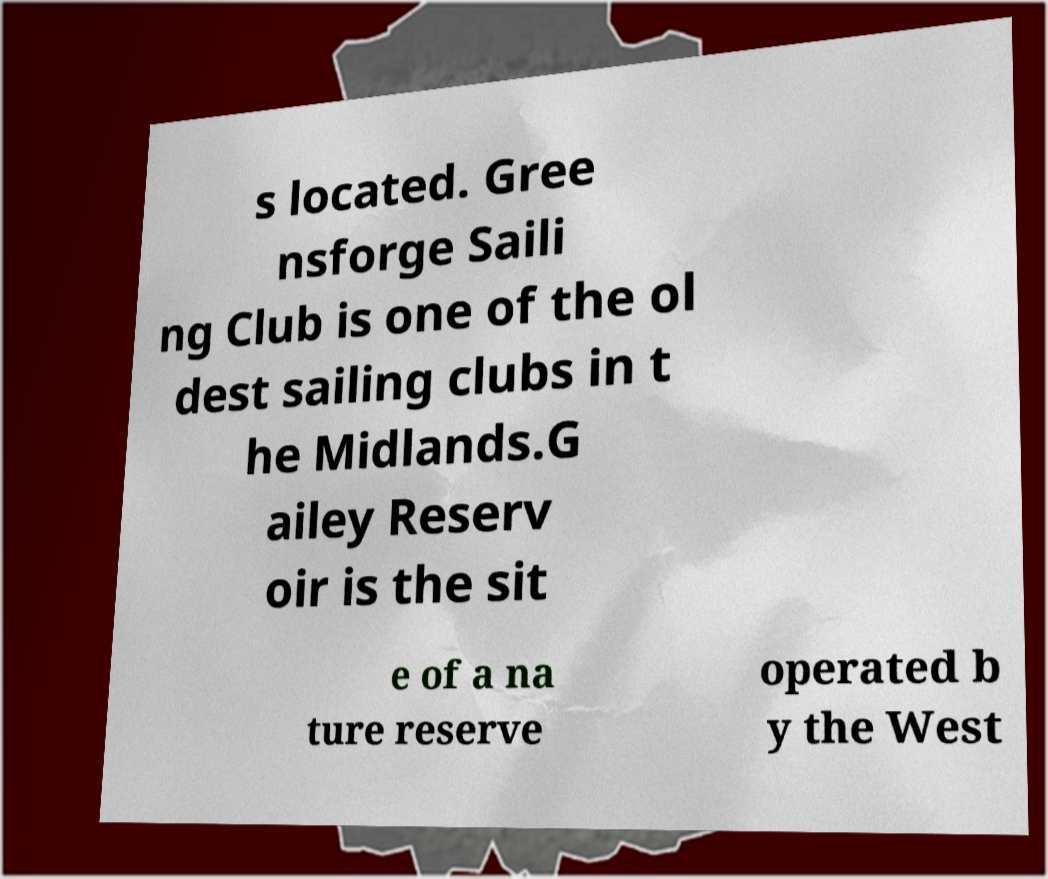For documentation purposes, I need the text within this image transcribed. Could you provide that? s located. Gree nsforge Saili ng Club is one of the ol dest sailing clubs in t he Midlands.G ailey Reserv oir is the sit e of a na ture reserve operated b y the West 